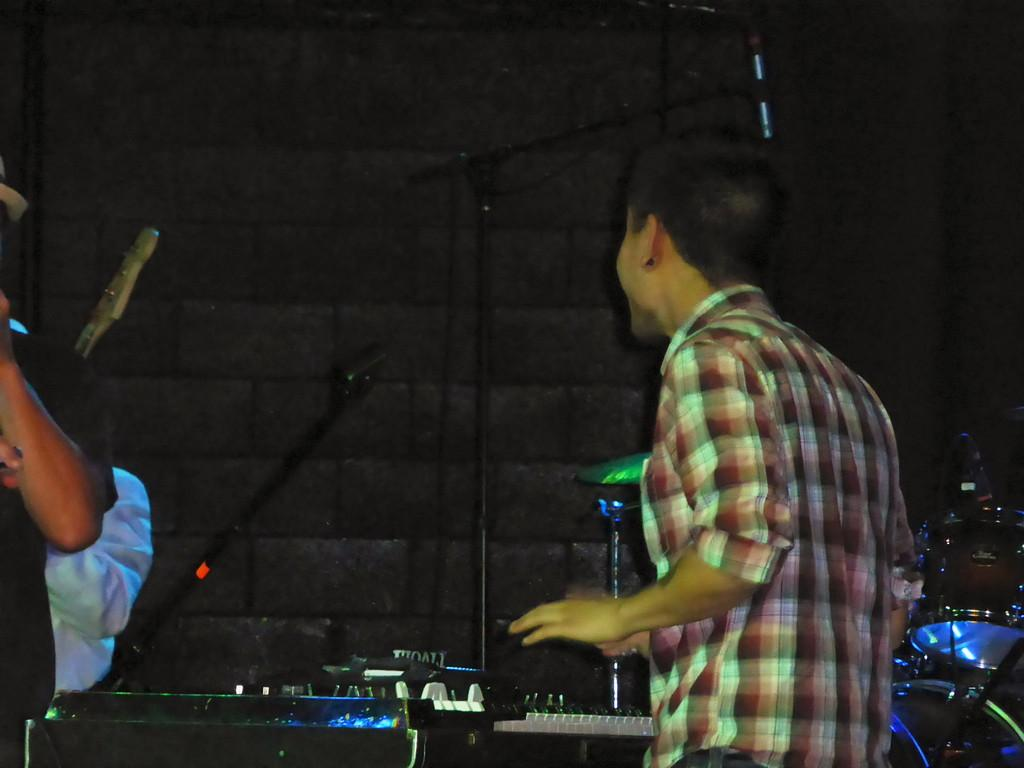How many people are in the image? There are three persons in the image. What are the persons doing in the image? They are likely playing musical instruments, as they are present in the image. Can you describe any equipment used by the persons in the image? Yes, there are microphones in the image. What can be seen in the background of the image? There is a wall in the background of the image. What type of wren can be seen perched on the microphone in the image? There is no wren present in the image; it features three persons and musical instruments. What is the best way to reach the stage from the image's perspective? The image does not provide information about a stage or a way to reach it, as it only shows three persons with musical instruments and microphones. 